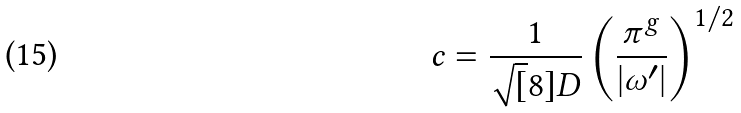Convert formula to latex. <formula><loc_0><loc_0><loc_500><loc_500>c = \frac { 1 } { \sqrt { [ } 8 ] { D } } \left ( \frac { \pi ^ { g } } { | \omega ^ { \prime } | } \right ) ^ { 1 / 2 }</formula> 